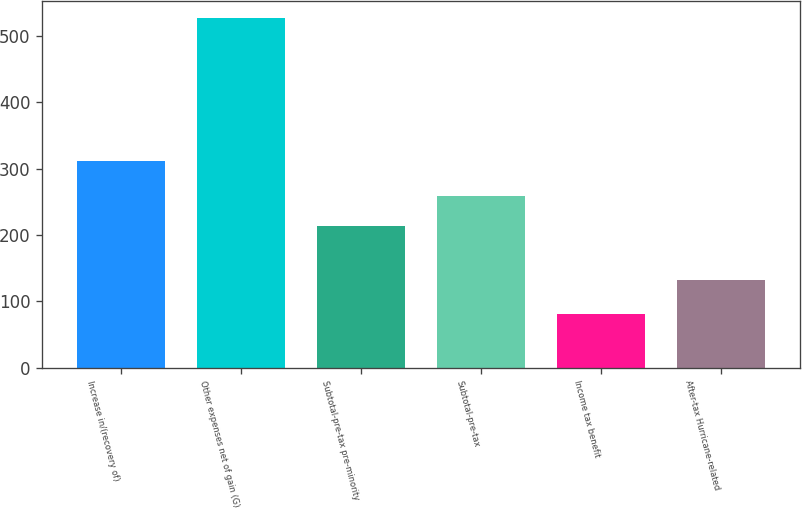<chart> <loc_0><loc_0><loc_500><loc_500><bar_chart><fcel>Increase in/(recovery of)<fcel>Other expenses net of gain (G)<fcel>Subtotal-pre-tax pre-minority<fcel>Subtotal-pre-tax<fcel>Income tax benefit<fcel>After-tax Hurricane-related<nl><fcel>312<fcel>526<fcel>214<fcel>258.5<fcel>81<fcel>133<nl></chart> 